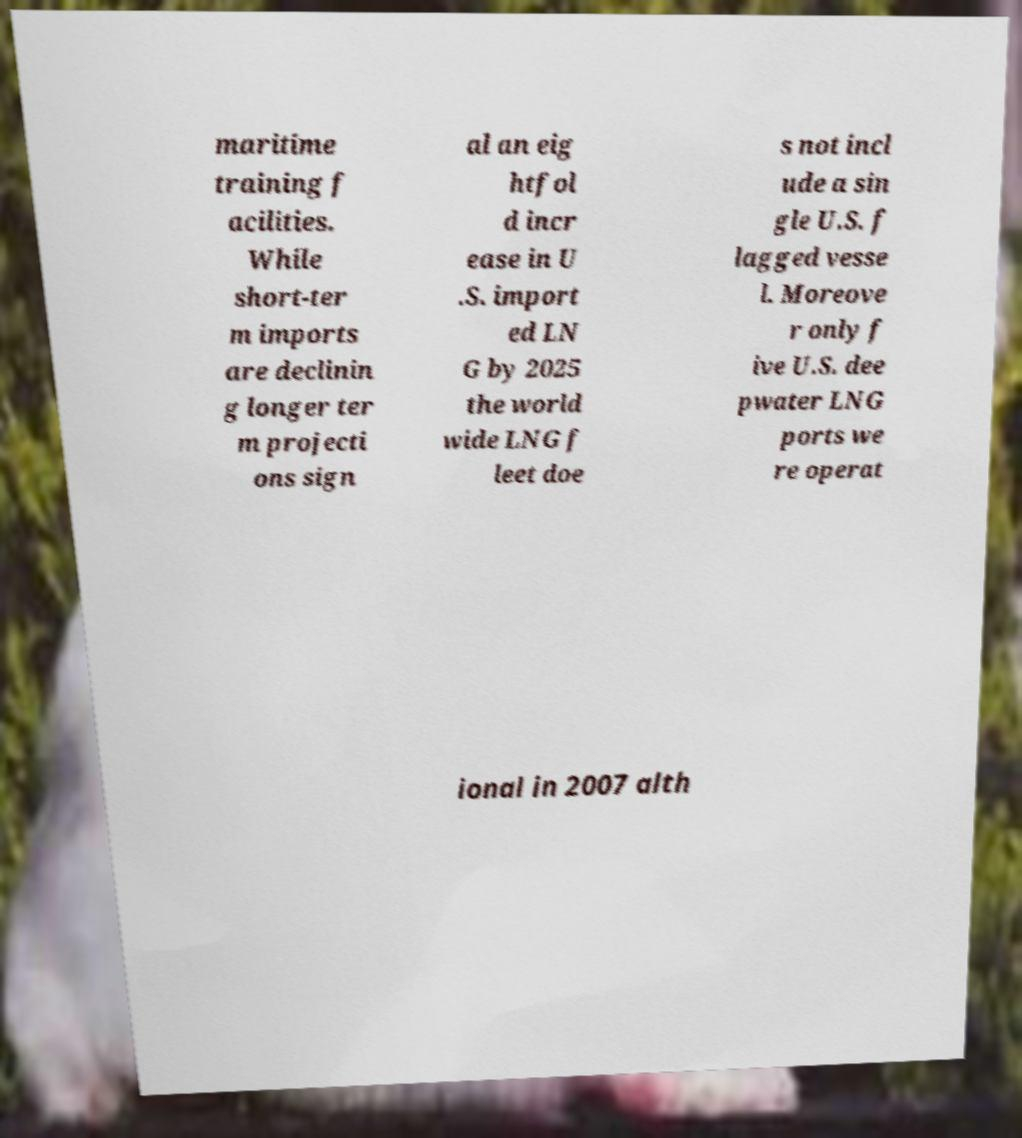Could you extract and type out the text from this image? maritime training f acilities. While short-ter m imports are declinin g longer ter m projecti ons sign al an eig htfol d incr ease in U .S. import ed LN G by 2025 the world wide LNG f leet doe s not incl ude a sin gle U.S. f lagged vesse l. Moreove r only f ive U.S. dee pwater LNG ports we re operat ional in 2007 alth 